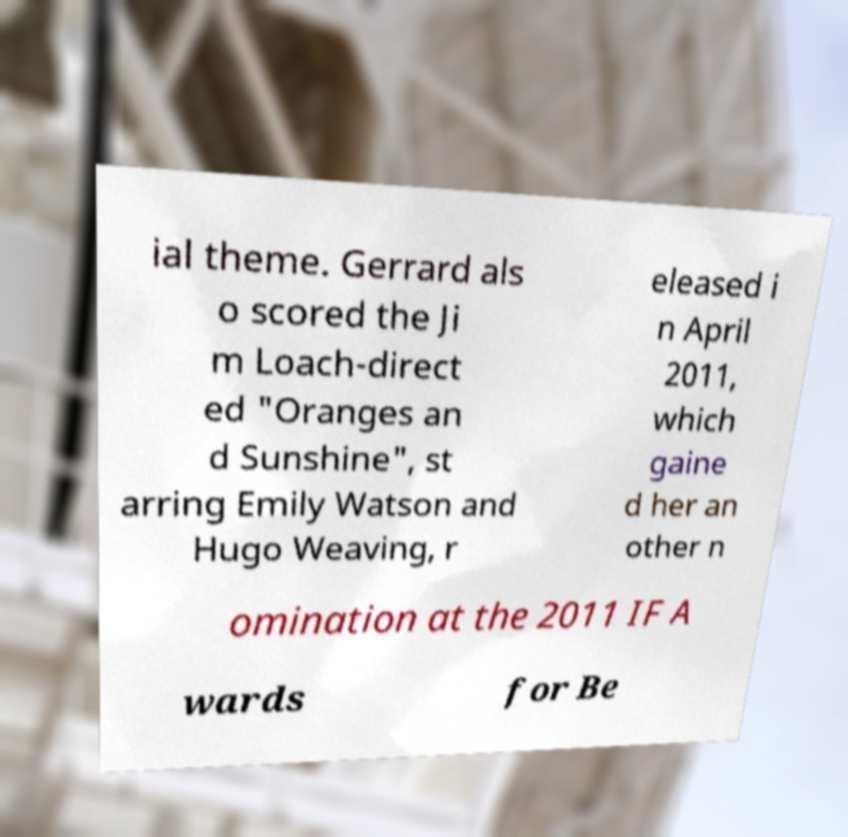I need the written content from this picture converted into text. Can you do that? ial theme. Gerrard als o scored the Ji m Loach-direct ed "Oranges an d Sunshine", st arring Emily Watson and Hugo Weaving, r eleased i n April 2011, which gaine d her an other n omination at the 2011 IF A wards for Be 